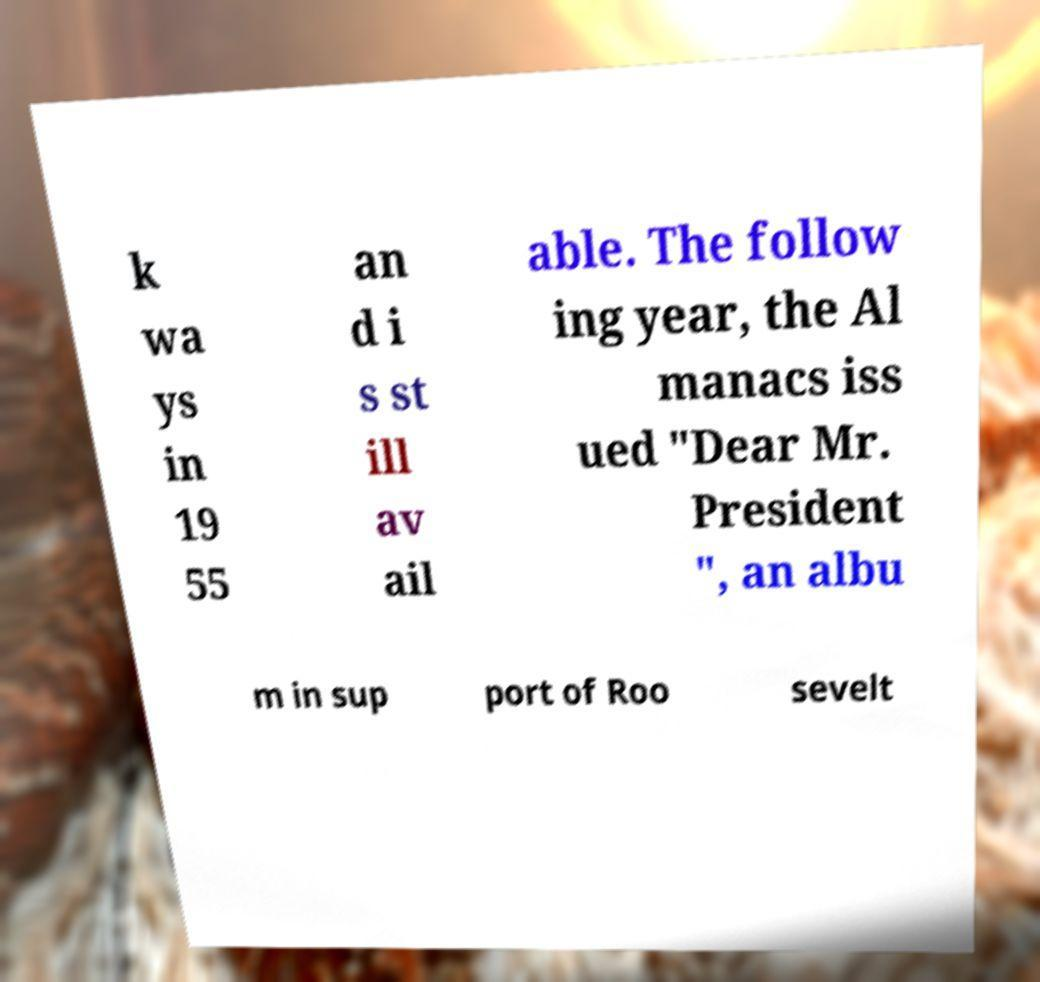Please read and relay the text visible in this image. What does it say? k wa ys in 19 55 an d i s st ill av ail able. The follow ing year, the Al manacs iss ued "Dear Mr. President ", an albu m in sup port of Roo sevelt 